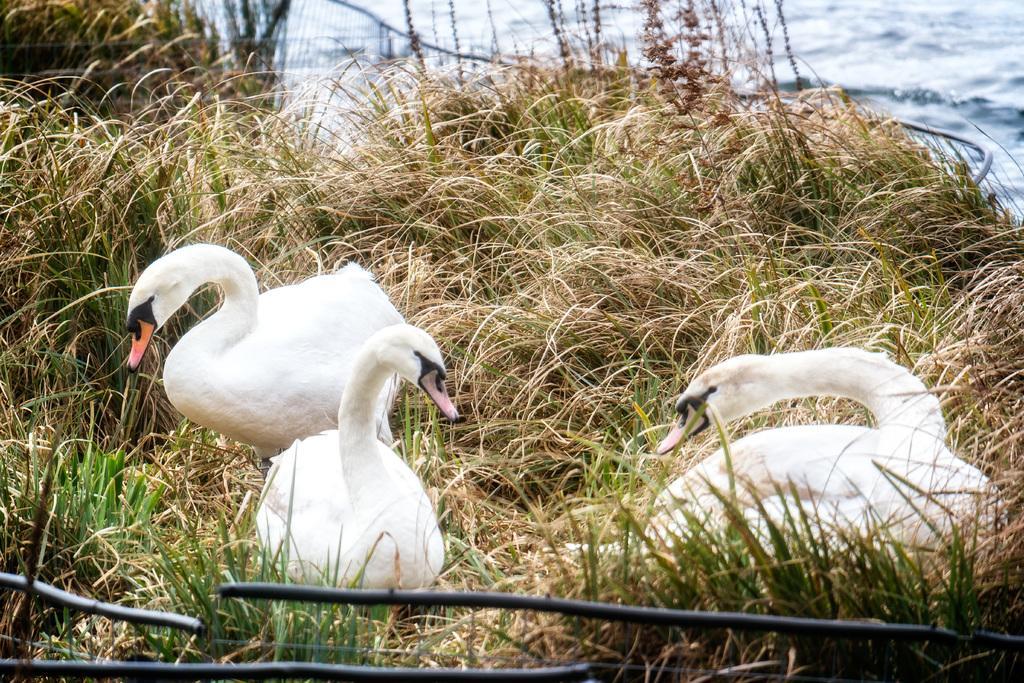Describe this image in one or two sentences. There are three Tundra swans which are white in color is on the grass and there is water in the background. 